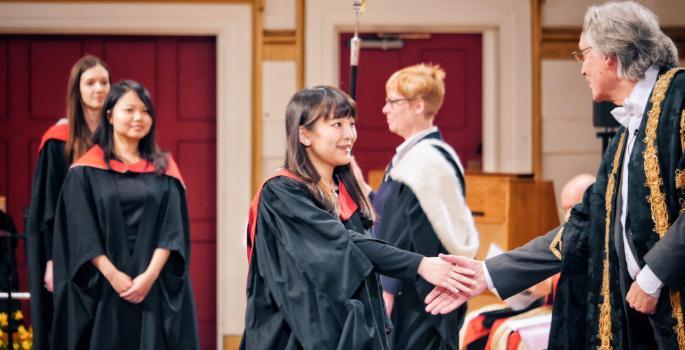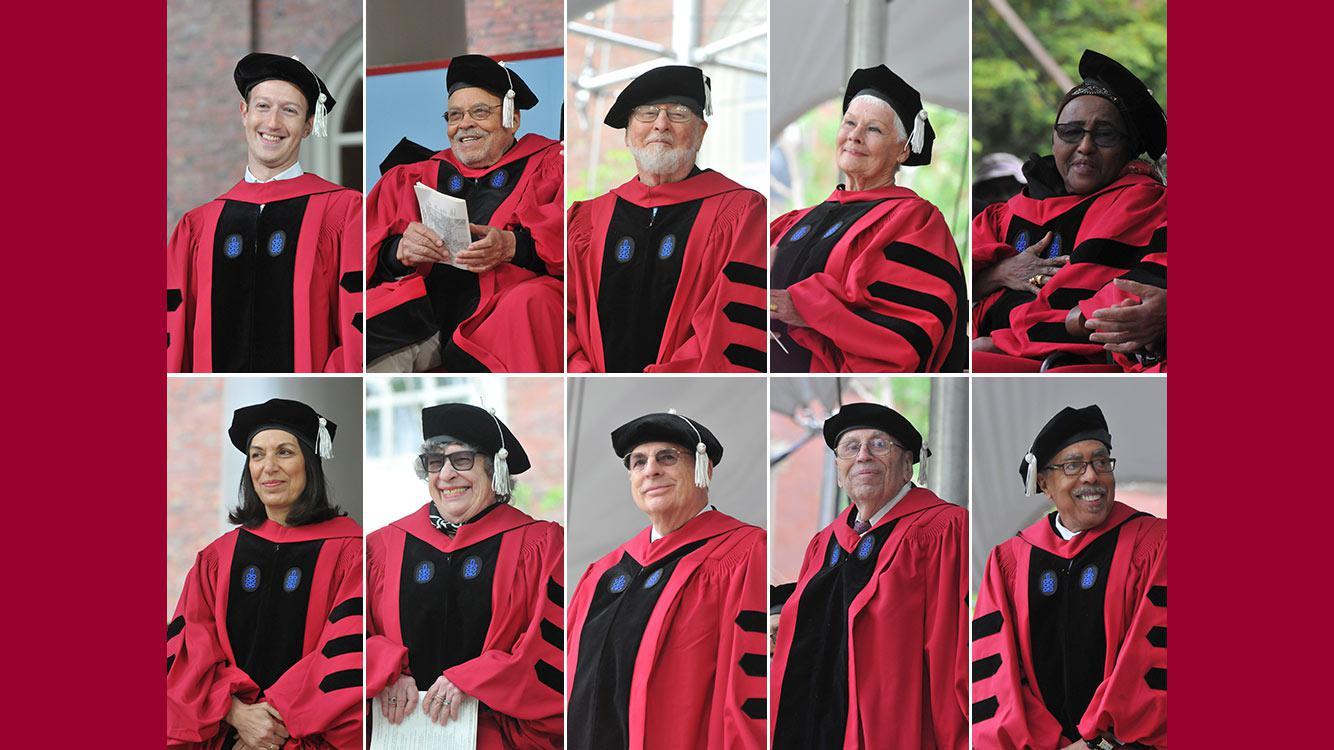The first image is the image on the left, the second image is the image on the right. For the images shown, is this caption "One of the images has one man and at least 3 women." true? Answer yes or no. Yes. The first image is the image on the left, the second image is the image on the right. For the images displayed, is the sentence "There are two graduates in the pair of images." factually correct? Answer yes or no. No. 